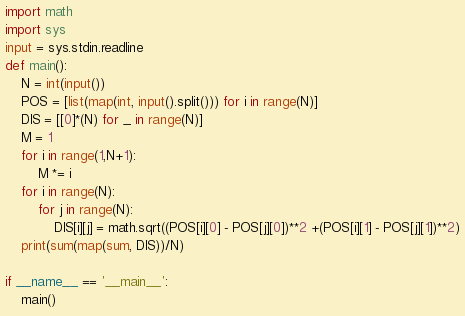<code> <loc_0><loc_0><loc_500><loc_500><_Python_>import math
import sys
input = sys.stdin.readline
def main():
    N = int(input())
    POS = [list(map(int, input().split())) for i in range(N)]
    DIS = [[0]*(N) for _ in range(N)]
    M = 1
    for i in range(1,N+1):
        M *= i
    for i in range(N):
        for j in range(N):
            DIS[i][j] = math.sqrt((POS[i][0] - POS[j][0])**2 +(POS[i][1] - POS[j][1])**2)
    print(sum(map(sum, DIS))/N)

if __name__ == '__main__':
    main()</code> 